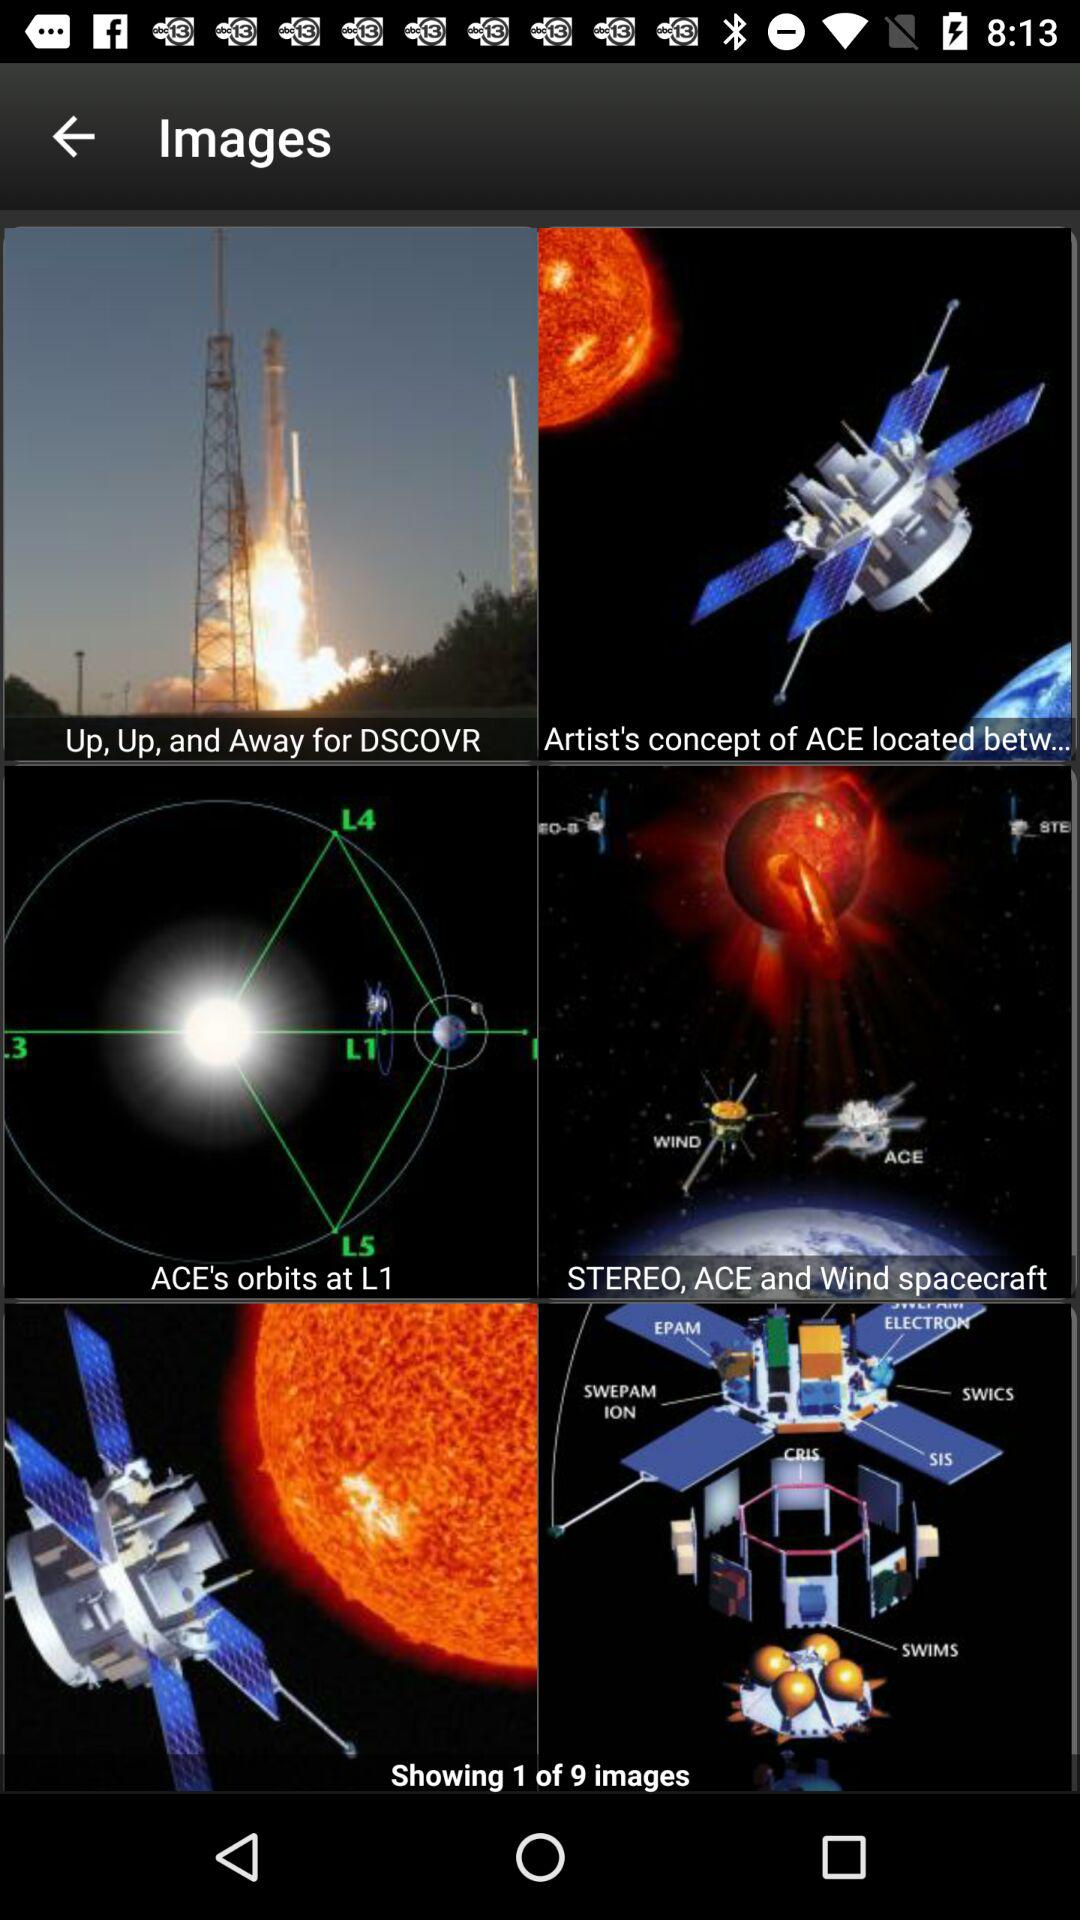What is the total number of given images? The total number of given images is 9. 